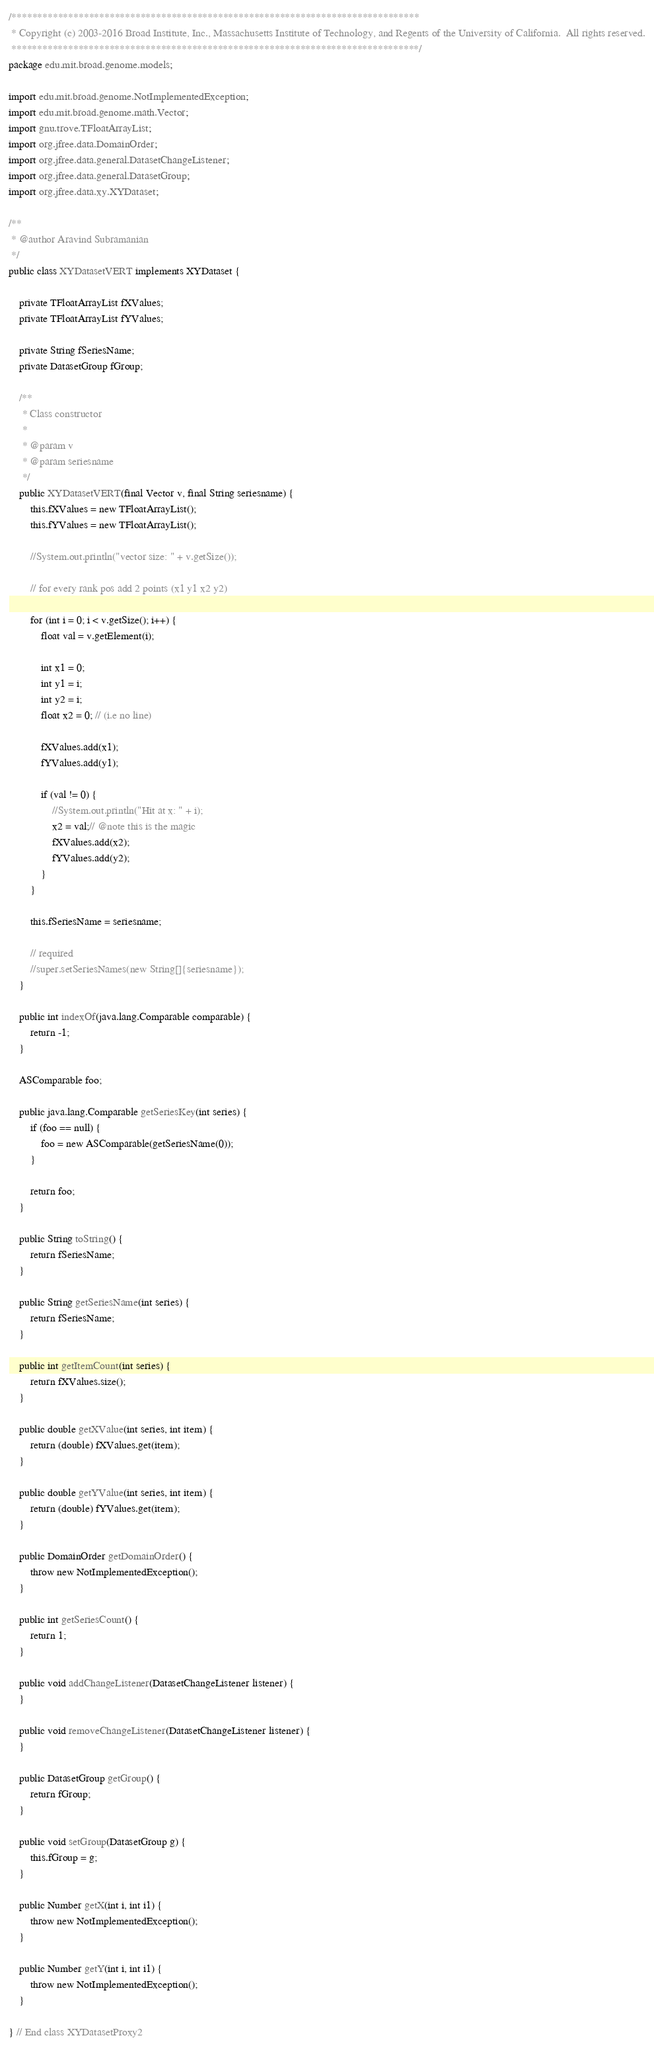<code> <loc_0><loc_0><loc_500><loc_500><_Java_>/*******************************************************************************
 * Copyright (c) 2003-2016 Broad Institute, Inc., Massachusetts Institute of Technology, and Regents of the University of California.  All rights reserved.
 *******************************************************************************/
package edu.mit.broad.genome.models;

import edu.mit.broad.genome.NotImplementedException;
import edu.mit.broad.genome.math.Vector;
import gnu.trove.TFloatArrayList;
import org.jfree.data.DomainOrder;
import org.jfree.data.general.DatasetChangeListener;
import org.jfree.data.general.DatasetGroup;
import org.jfree.data.xy.XYDataset;

/**
 * @author Aravind Subramanian
 */
public class XYDatasetVERT implements XYDataset {

    private TFloatArrayList fXValues;
    private TFloatArrayList fYValues;

    private String fSeriesName;
    private DatasetGroup fGroup;

    /**
     * Class constructor
     *
     * @param v
     * @param seriesname
     */
    public XYDatasetVERT(final Vector v, final String seriesname) {
        this.fXValues = new TFloatArrayList();
        this.fYValues = new TFloatArrayList();

        //System.out.println("vector size: " + v.getSize());

        // for every rank pos add 2 points (x1 y1 x2 y2)

        for (int i = 0; i < v.getSize(); i++) {
            float val = v.getElement(i);

            int x1 = 0;
            int y1 = i;
            int y2 = i;
            float x2 = 0; // (i.e no line)

            fXValues.add(x1);
            fYValues.add(y1);

            if (val != 0) {
                //System.out.println("Hit at x: " + i);
                x2 = val;// @note this is the magic
                fXValues.add(x2);
                fYValues.add(y2);
            }
        }

        this.fSeriesName = seriesname;

        // required
        //super.setSeriesNames(new String[]{seriesname});
    }

    public int indexOf(java.lang.Comparable comparable) {
        return -1;
    }

    ASComparable foo;

    public java.lang.Comparable getSeriesKey(int series) {
        if (foo == null) {
            foo = new ASComparable(getSeriesName(0));
        }

        return foo;
    }

    public String toString() {
        return fSeriesName;
    }

    public String getSeriesName(int series) {
        return fSeriesName;
    }

    public int getItemCount(int series) {
        return fXValues.size();
    }

    public double getXValue(int series, int item) {
        return (double) fXValues.get(item);
    }

    public double getYValue(int series, int item) {
        return (double) fYValues.get(item);
    }

    public DomainOrder getDomainOrder() {
        throw new NotImplementedException();
    }

    public int getSeriesCount() {
        return 1;
    }

    public void addChangeListener(DatasetChangeListener listener) {
    }

    public void removeChangeListener(DatasetChangeListener listener) {
    }

    public DatasetGroup getGroup() {
        return fGroup;
    }

    public void setGroup(DatasetGroup g) {
        this.fGroup = g;
    }

    public Number getX(int i, int i1) {
        throw new NotImplementedException();
    }

    public Number getY(int i, int i1) {
        throw new NotImplementedException();
    }

} // End class XYDatasetProxy2</code> 